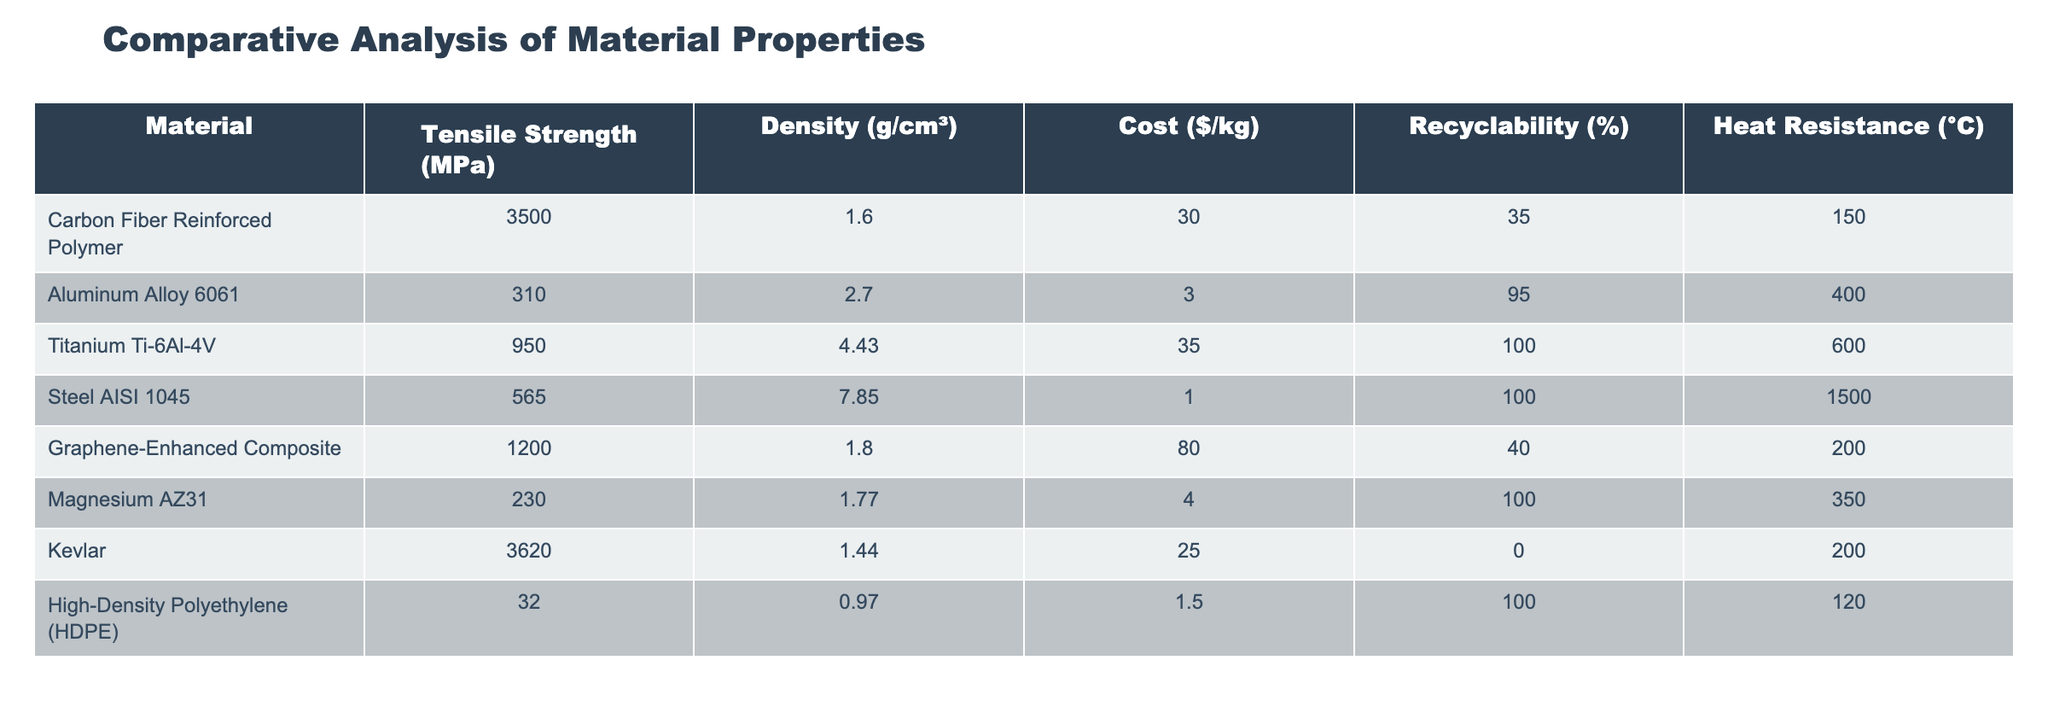What is the tensile strength of Graphene-Enhanced Composite? The table lists the tensile strength of Graphene-Enhanced Composite as 1200 MPa.
Answer: 1200 MPa Which material has the highest cost per kilogram? By examining the cost column, the material with the highest cost is Graphene-Enhanced Composite, priced at $80/kg.
Answer: Graphene-Enhanced Composite What is the average density of the materials listed? The total density values are 1.6 + 2.7 + 4.43 + 7.85 + 1.8 + 1.77 + 1.44 + 0.97 = 22.53 g/cm³. There are 8 materials, thus the average density is 22.53/8 = 2.81625 g/cm³.
Answer: 2.82 g/cm³ Is the recyclability of Aluminum Alloy 6061 greater than that of High-Density Polyethylene? The recyclability of Aluminum Alloy 6061 is 95% and for HDPE it is 100%. Since 100% is greater than 95%, the statement is false.
Answer: No What is the difference in heat resistance between Titanium Ti-6Al-4V and Steel AISI 1045? The heat resistance of Titanium Ti-6Al-4V is 600°C and that of Steel AISI 1045 is 1500°C. The difference is 1500 - 600 = 900°C.
Answer: 900°C Which material has a density less than 2 g/cm³ and what is its cost per kilogram? By checking the density column, High-Density Polyethylene (HDPE) has a density of 0.97 g/cm³, which is less than 2 g/cm³. Its cost is $1.5/kg.
Answer: HDPE; $1.5/kg Is it true that Kevlar has better tensile strength than Aluminum Alloy 6061? The tensile strength of Kevlar is 3620 MPa, while that of Aluminum Alloy 6061 is 310 MPa. Since 3620 is greater than 310, the statement is true.
Answer: Yes If we add the tensile strength of Steel AISI 1045 and Magnesium AZ31, what do we get? Steel AISI 1045 has a tensile strength of 565 MPa, and Magnesium AZ31 has 230 MPa. The total tensile strength is 565 + 230 = 795 MPa.
Answer: 795 MPa 